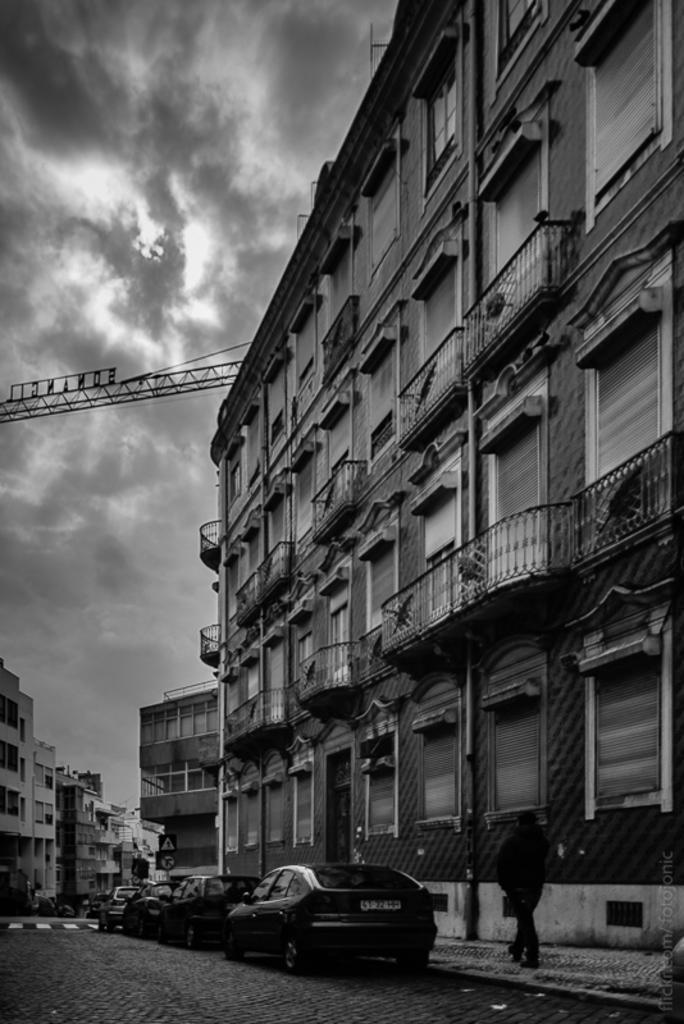Could you give a brief overview of what you see in this image? In this black and white image, we can see some cars. There are buildings in the middle of the image. There is a sky on the left side of the image. 